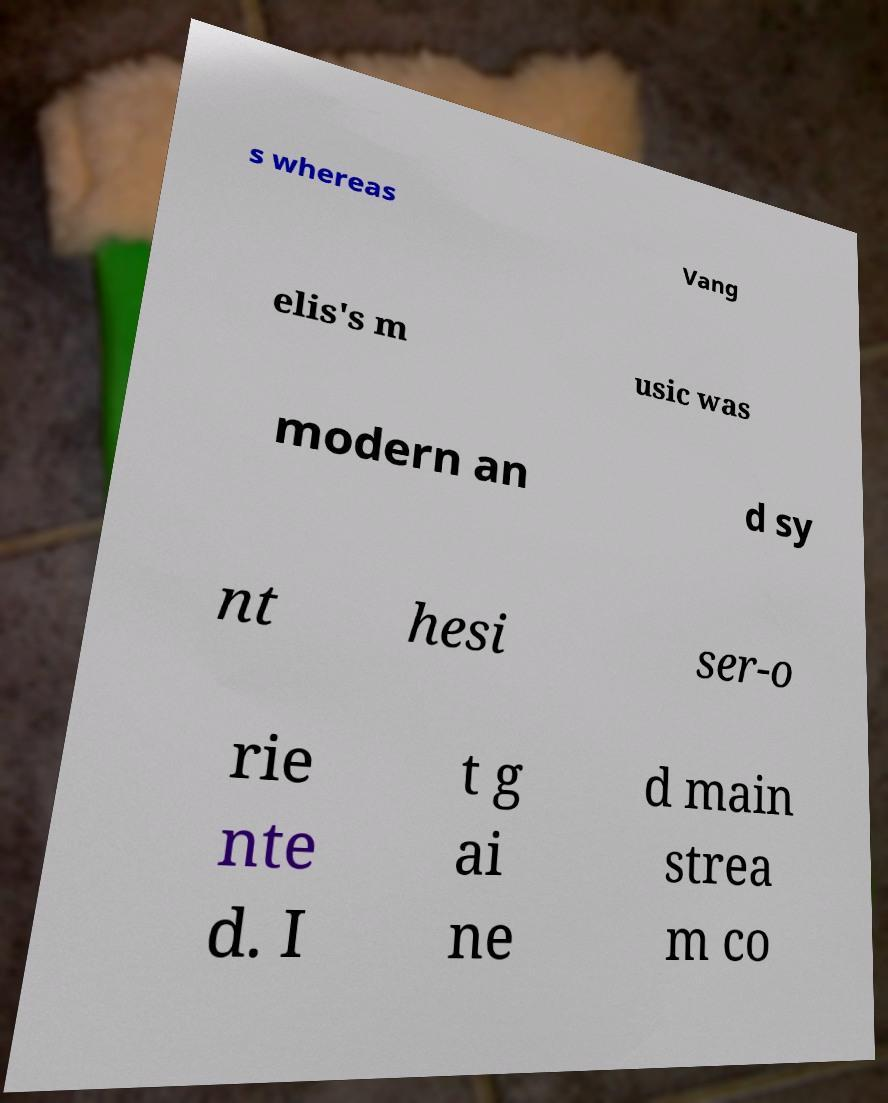Please read and relay the text visible in this image. What does it say? s whereas Vang elis's m usic was modern an d sy nt hesi ser-o rie nte d. I t g ai ne d main strea m co 